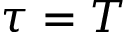Convert formula to latex. <formula><loc_0><loc_0><loc_500><loc_500>\tau = T</formula> 